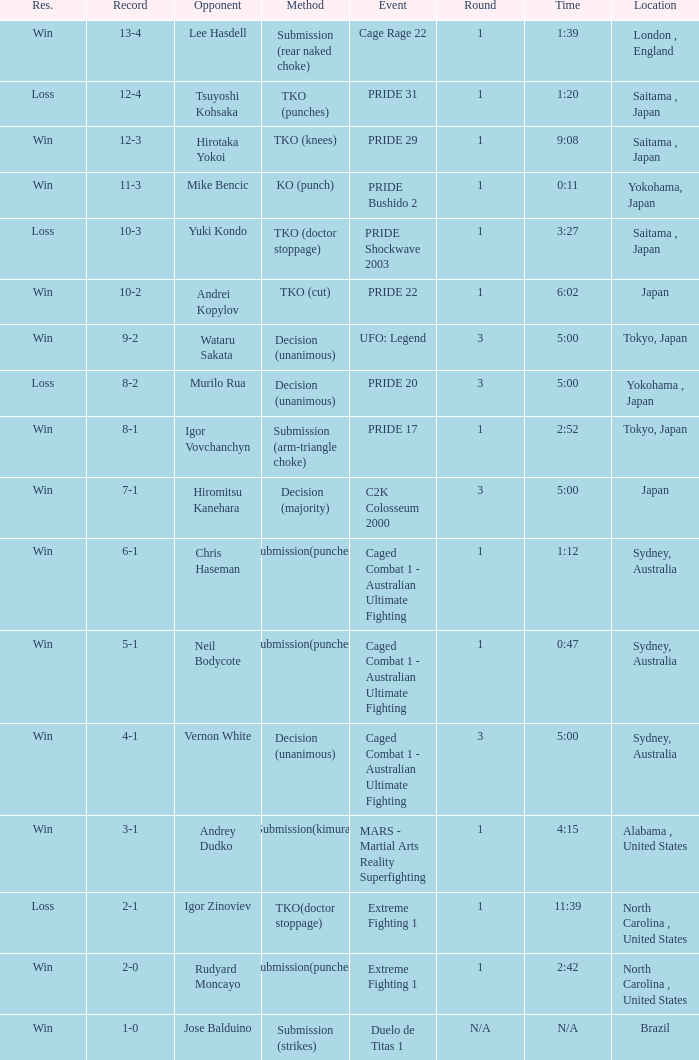Which Res has a Method of decision (unanimous) and an Opponent of Wataru Sakata? Win. 